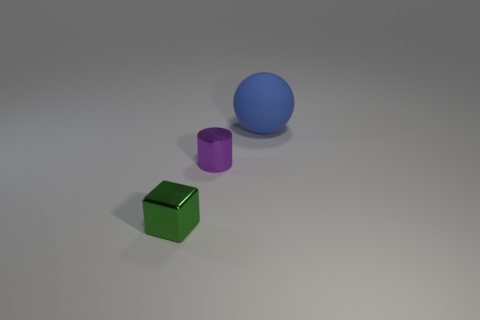Add 3 rubber things. How many objects exist? 6 Subtract all balls. How many objects are left? 2 Subtract 1 green blocks. How many objects are left? 2 Subtract all small purple shiny cylinders. Subtract all metal blocks. How many objects are left? 1 Add 2 metallic objects. How many metallic objects are left? 4 Add 2 tiny green objects. How many tiny green objects exist? 3 